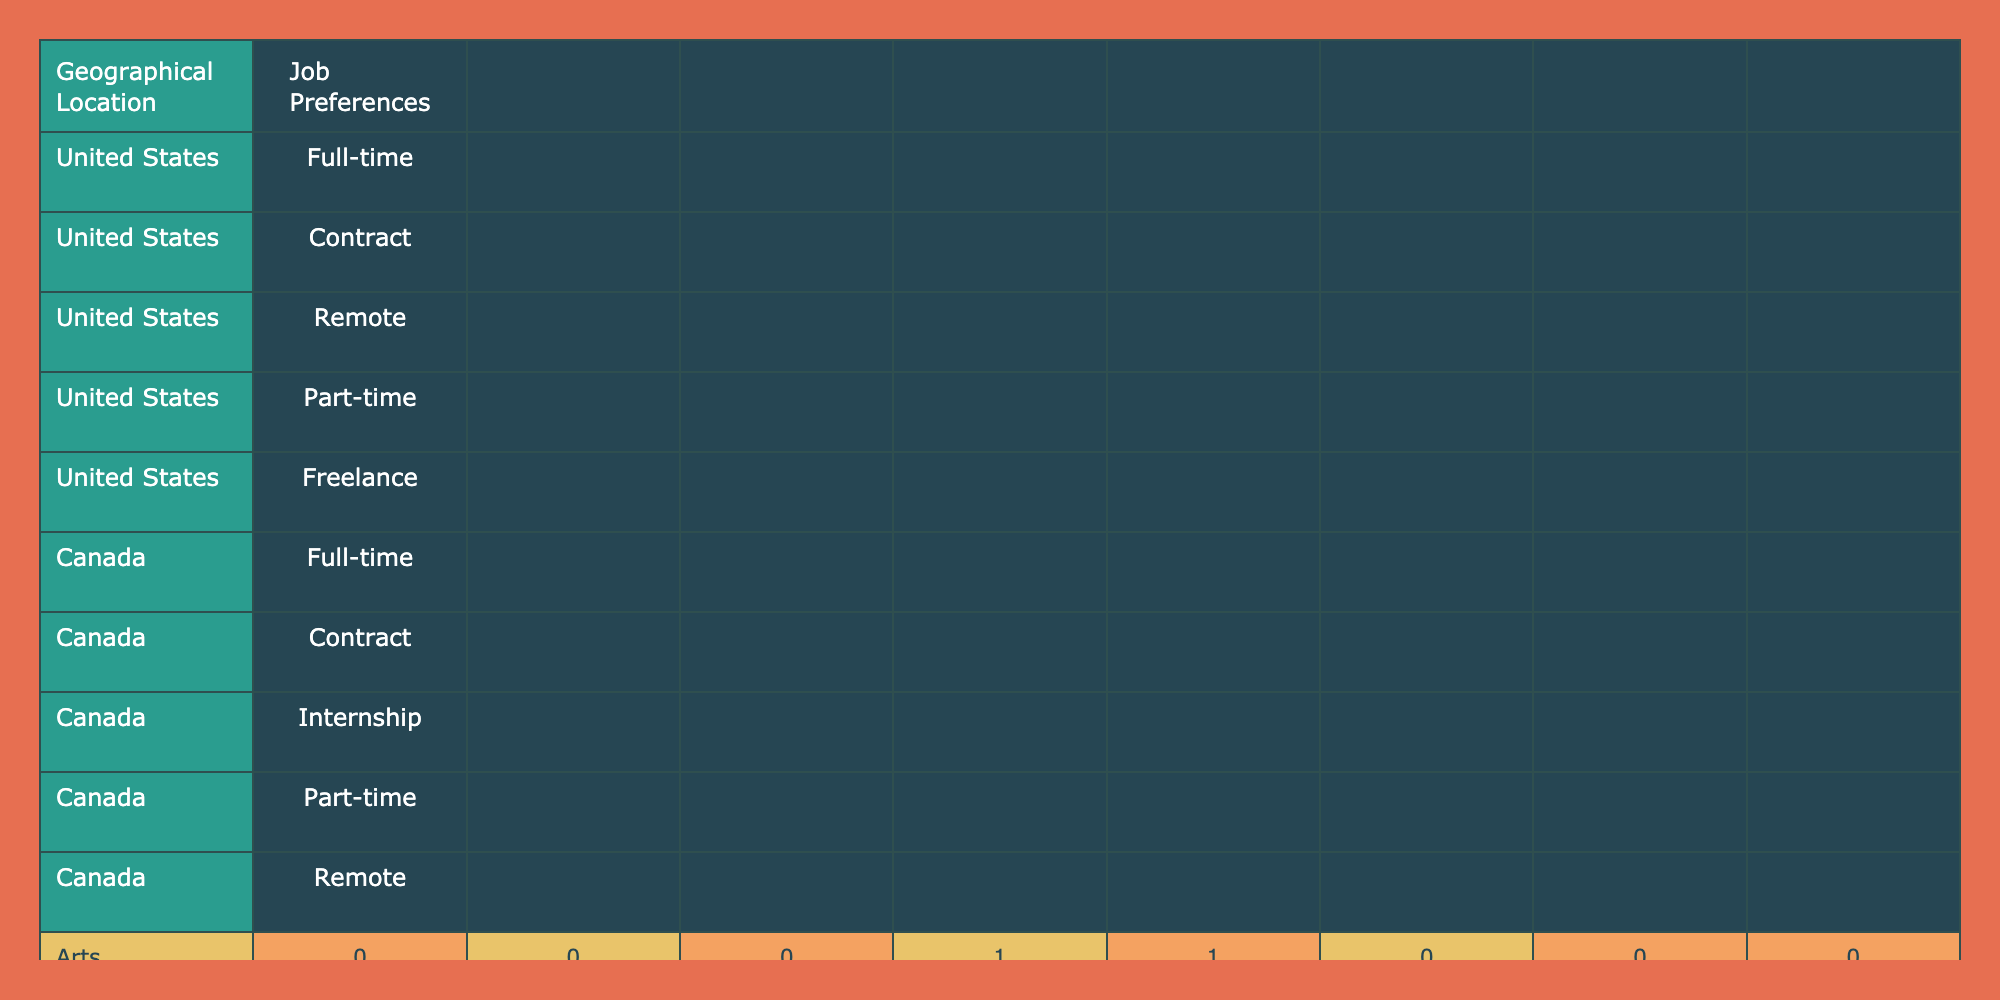What job preference do most Computer Science graduates in the United States choose? In the table, under the geographical location of the United States, the job preference for Computer Science graduates is listed as Remote. There are no other preferences for this field in this location.
Answer: Remote Which field of study has the highest number of contract job preferences in Canada? Looking at the job preferences in Canada, only the Engineering and Social Sciences fields have contract preference listed. Engineering has one instance of contract, while Social Sciences also has one. There are no other fields with contract preferences, making these two equal.
Answer: Engineering and Social Sciences True or False: All Health Sciences graduates in the United States prefer full-time jobs. In the table, it shows that Health Sciences graduates in the United States have a preference for Part-time jobs, not exclusively full-time. Therefore, the statement is false.
Answer: False What is the total count of full-time job preferences for all fields of study combined in the United States? By examining the United States row, we can count the full-time preferences from the fields: Engineering (1), Business (1), Computer Science (0), Health Sciences (0), Arts (0), Education (1), Social Sciences (1), leading to a total of 1 + 1 + 0 + 0 + 0 + 1 + 1 = 4.
Answer: 4 How many different job preferences do graduates from the Education field in Canada show? In the table, these graduates have two distinct job preferences: Internship and Full-time. By counting these, we see that there are no repetitions. Therefore, the unique job preferences for graduates from this field in Canada total to two.
Answer: 2 Which geographical location shows a preference for Remote jobs among Environmental Studies graduates? Upon checking the row for Environmental Studies, it is clear that only the United States offers a Remote job preference. Thus, the geographical location showing this preference is the United States.
Answer: United States Which geographical location prefers Freelance jobs for Arts graduates? In the table, it shows that the preference for Freelance for Arts graduates is listed under the United States. No other geographical location is indicated for this job preference in connection with Arts.
Answer: United States Are there more job preferences in Canada than in the United States across all fields of study combined? To answer this, we compare preferences for both geographical locations combined. The total job preferences in the table are 8 for the United States (including all job types) and 8 for Canada. Since there are no preferences omitted, they are actually equal, not more in one than the other.
Answer: No 